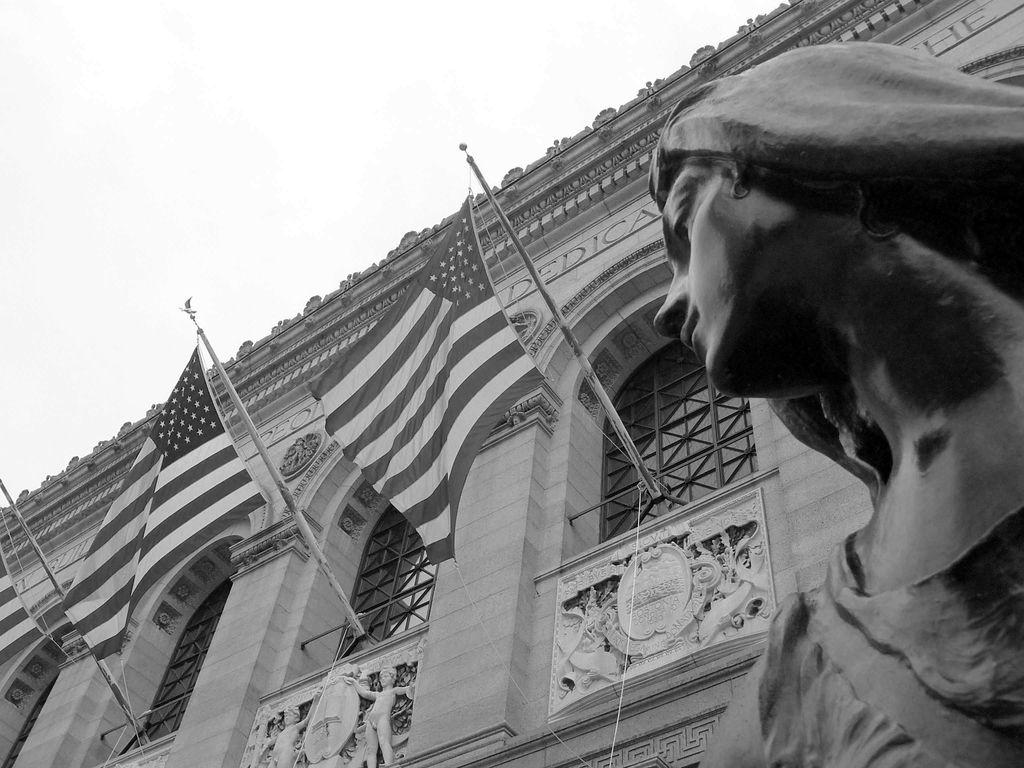What type of structure is visible in the picture? There is a building in the picture. What else can be seen flying in the picture? There are flags in the picture. Can you read any text in the picture? There is text on a wall in the picture. What is located on the right side of the picture? There is a statue on the right side of the picture. How would you describe the weather in the picture? The sky is cloudy in the picture. Where is the nest of the learning bird located in the picture? There is no nest or learning bird present in the picture. What is the fifth element in the picture? The provided facts do not mention a fifth element in the picture. 